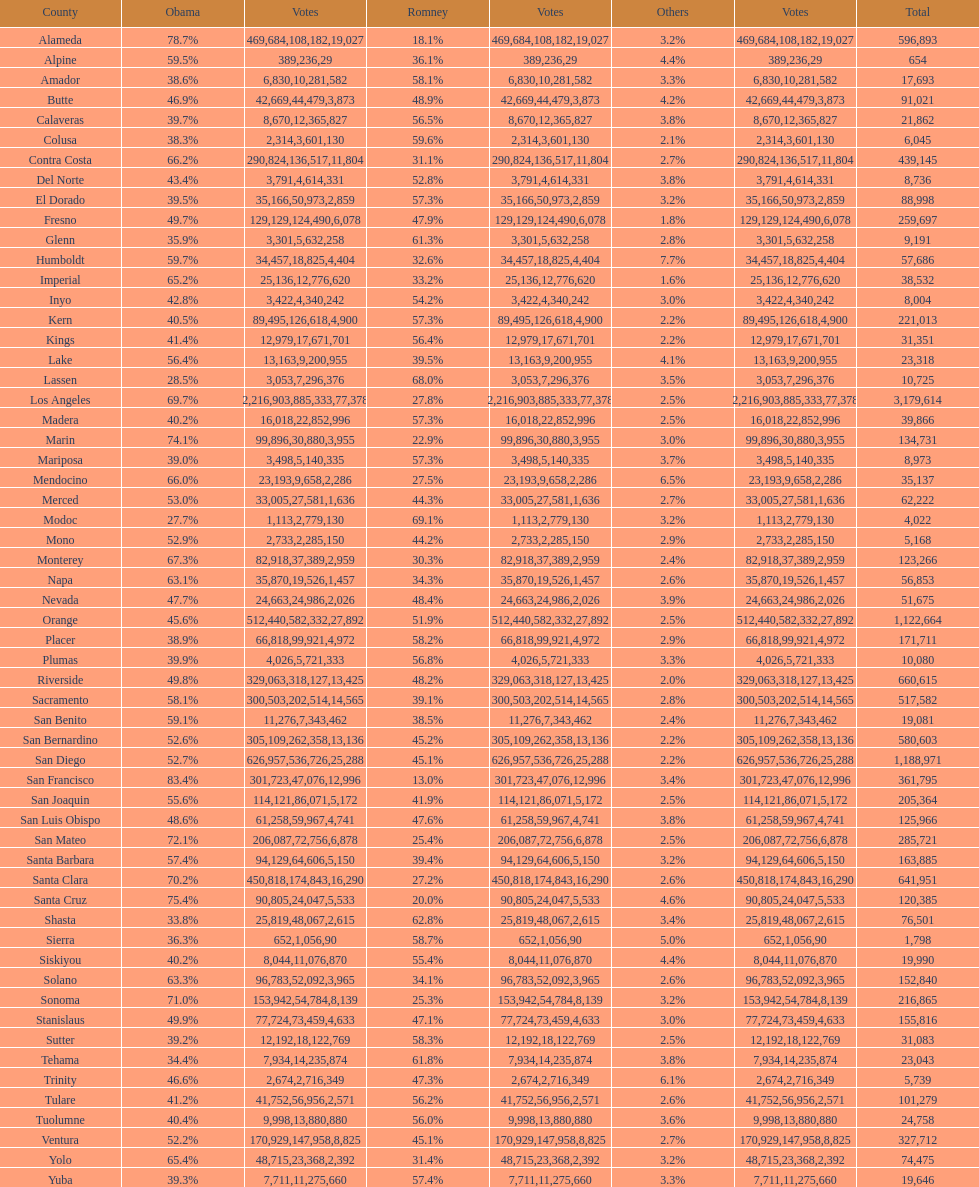What is the number of votes for obama for del norte and el dorado counties? 38957. 